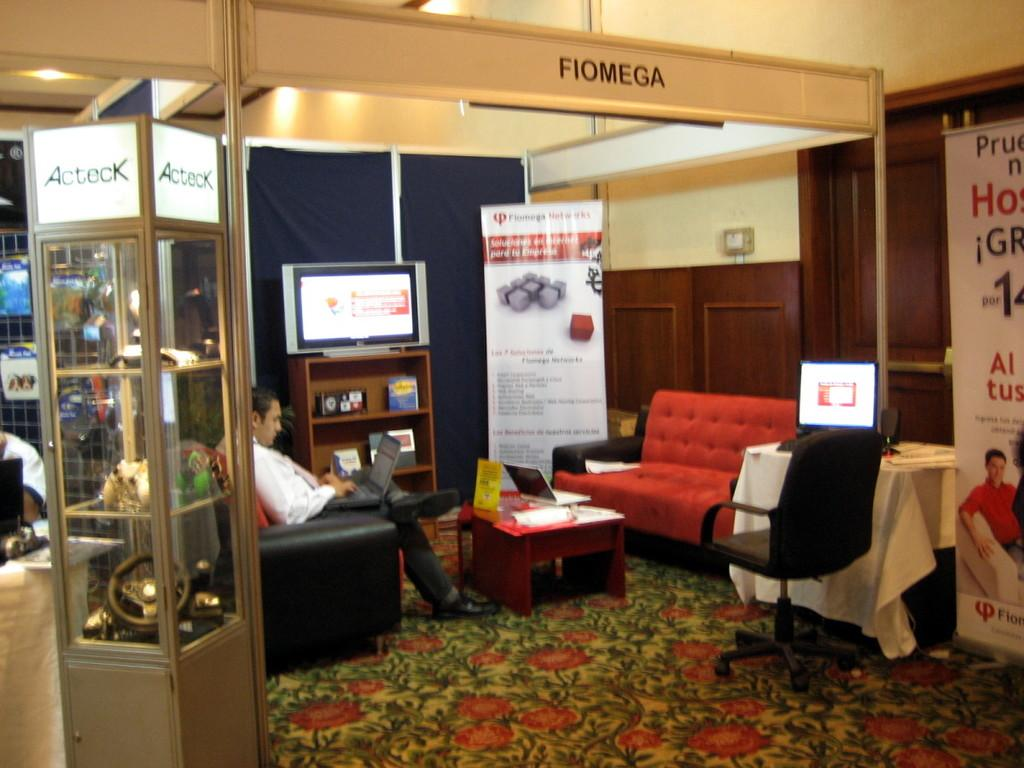What is the person in the image doing? The person is sitting on a chair and working on a laptop. What can be seen on the walls in the room? There are hoardings on the walls in the room. What electronic device is present in the room? There is a TV in the room. What type of furniture is in the room? There are cupboards and a table in the room. What is the primary architectural feature in the room? There is a wall in the room. What type of faucet is visible in the image? There is no faucet present in the image. How many planes are flying in the room in the image? There are no planes visible in the room in the image. 